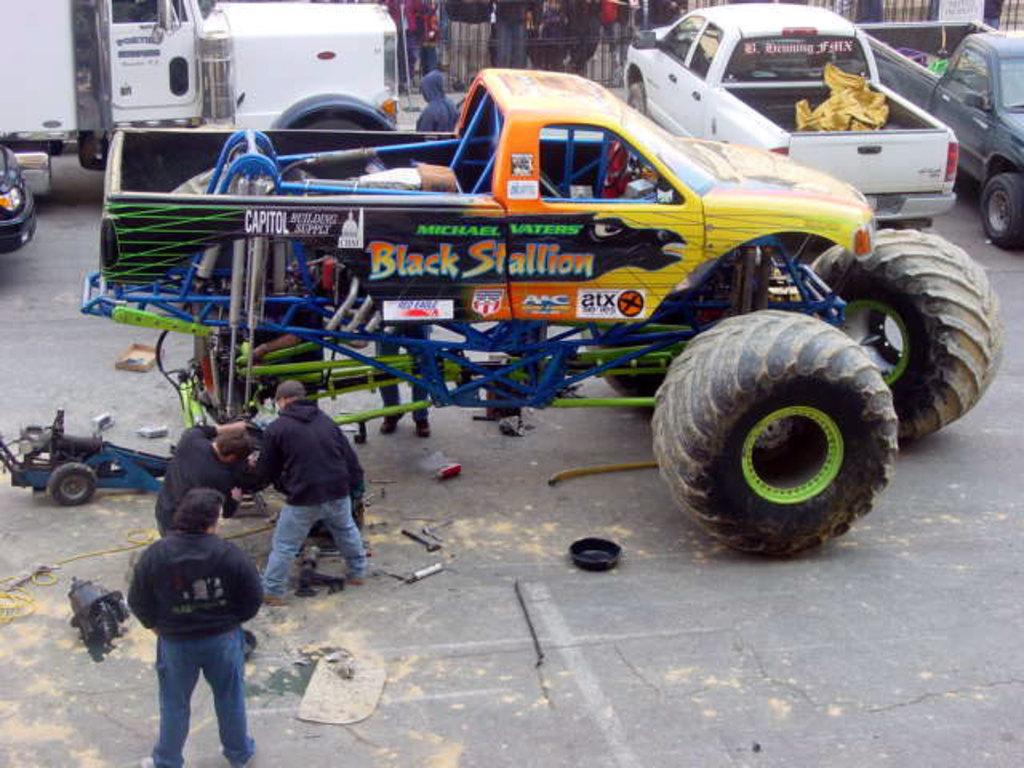<image>
Share a concise interpretation of the image provided. A group of men are working on a monster truck that says Black Stallion on the side. 